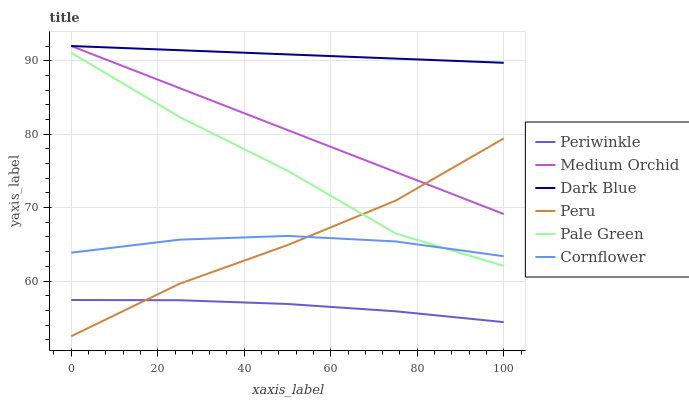Does Periwinkle have the minimum area under the curve?
Answer yes or no. Yes. Does Dark Blue have the maximum area under the curve?
Answer yes or no. Yes. Does Medium Orchid have the minimum area under the curve?
Answer yes or no. No. Does Medium Orchid have the maximum area under the curve?
Answer yes or no. No. Is Dark Blue the smoothest?
Answer yes or no. Yes. Is Pale Green the roughest?
Answer yes or no. Yes. Is Medium Orchid the smoothest?
Answer yes or no. No. Is Medium Orchid the roughest?
Answer yes or no. No. Does Peru have the lowest value?
Answer yes or no. Yes. Does Medium Orchid have the lowest value?
Answer yes or no. No. Does Dark Blue have the highest value?
Answer yes or no. Yes. Does Pale Green have the highest value?
Answer yes or no. No. Is Pale Green less than Medium Orchid?
Answer yes or no. Yes. Is Dark Blue greater than Periwinkle?
Answer yes or no. Yes. Does Peru intersect Pale Green?
Answer yes or no. Yes. Is Peru less than Pale Green?
Answer yes or no. No. Is Peru greater than Pale Green?
Answer yes or no. No. Does Pale Green intersect Medium Orchid?
Answer yes or no. No. 